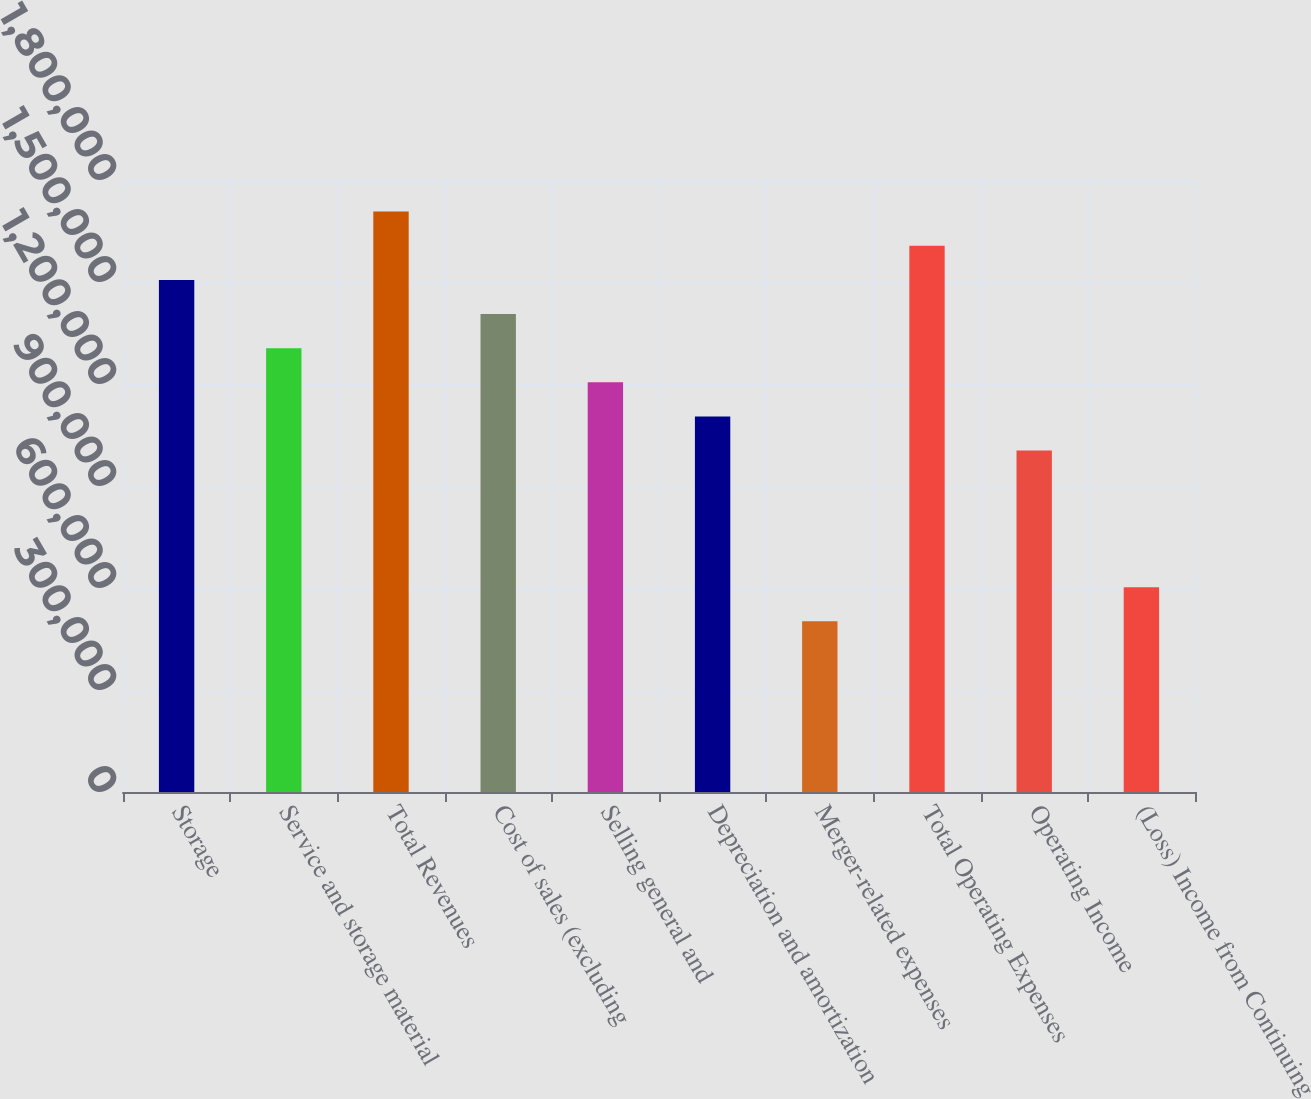Convert chart to OTSL. <chart><loc_0><loc_0><loc_500><loc_500><bar_chart><fcel>Storage<fcel>Service and storage material<fcel>Total Revenues<fcel>Cost of sales (excluding<fcel>Selling general and<fcel>Depreciation and amortization<fcel>Merger-related expenses<fcel>Total Operating Expenses<fcel>Operating Income<fcel>(Loss) Income from Continuing<nl><fcel>1.50625e+06<fcel>1.30541e+06<fcel>1.70708e+06<fcel>1.40583e+06<fcel>1.205e+06<fcel>1.10458e+06<fcel>502083<fcel>1.60666e+06<fcel>1.00417e+06<fcel>602499<nl></chart> 